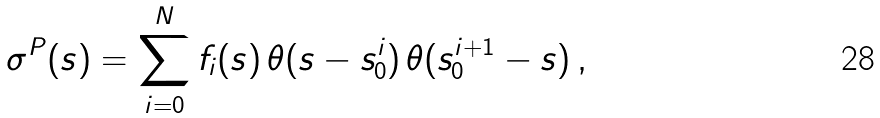Convert formula to latex. <formula><loc_0><loc_0><loc_500><loc_500>\sigma ^ { P } ( s ) = \sum _ { i = 0 } ^ { N } f _ { i } ( s ) \, \theta ( s - s _ { 0 } ^ { i } ) \, \theta ( s _ { 0 } ^ { i + 1 } - s ) \, ,</formula> 